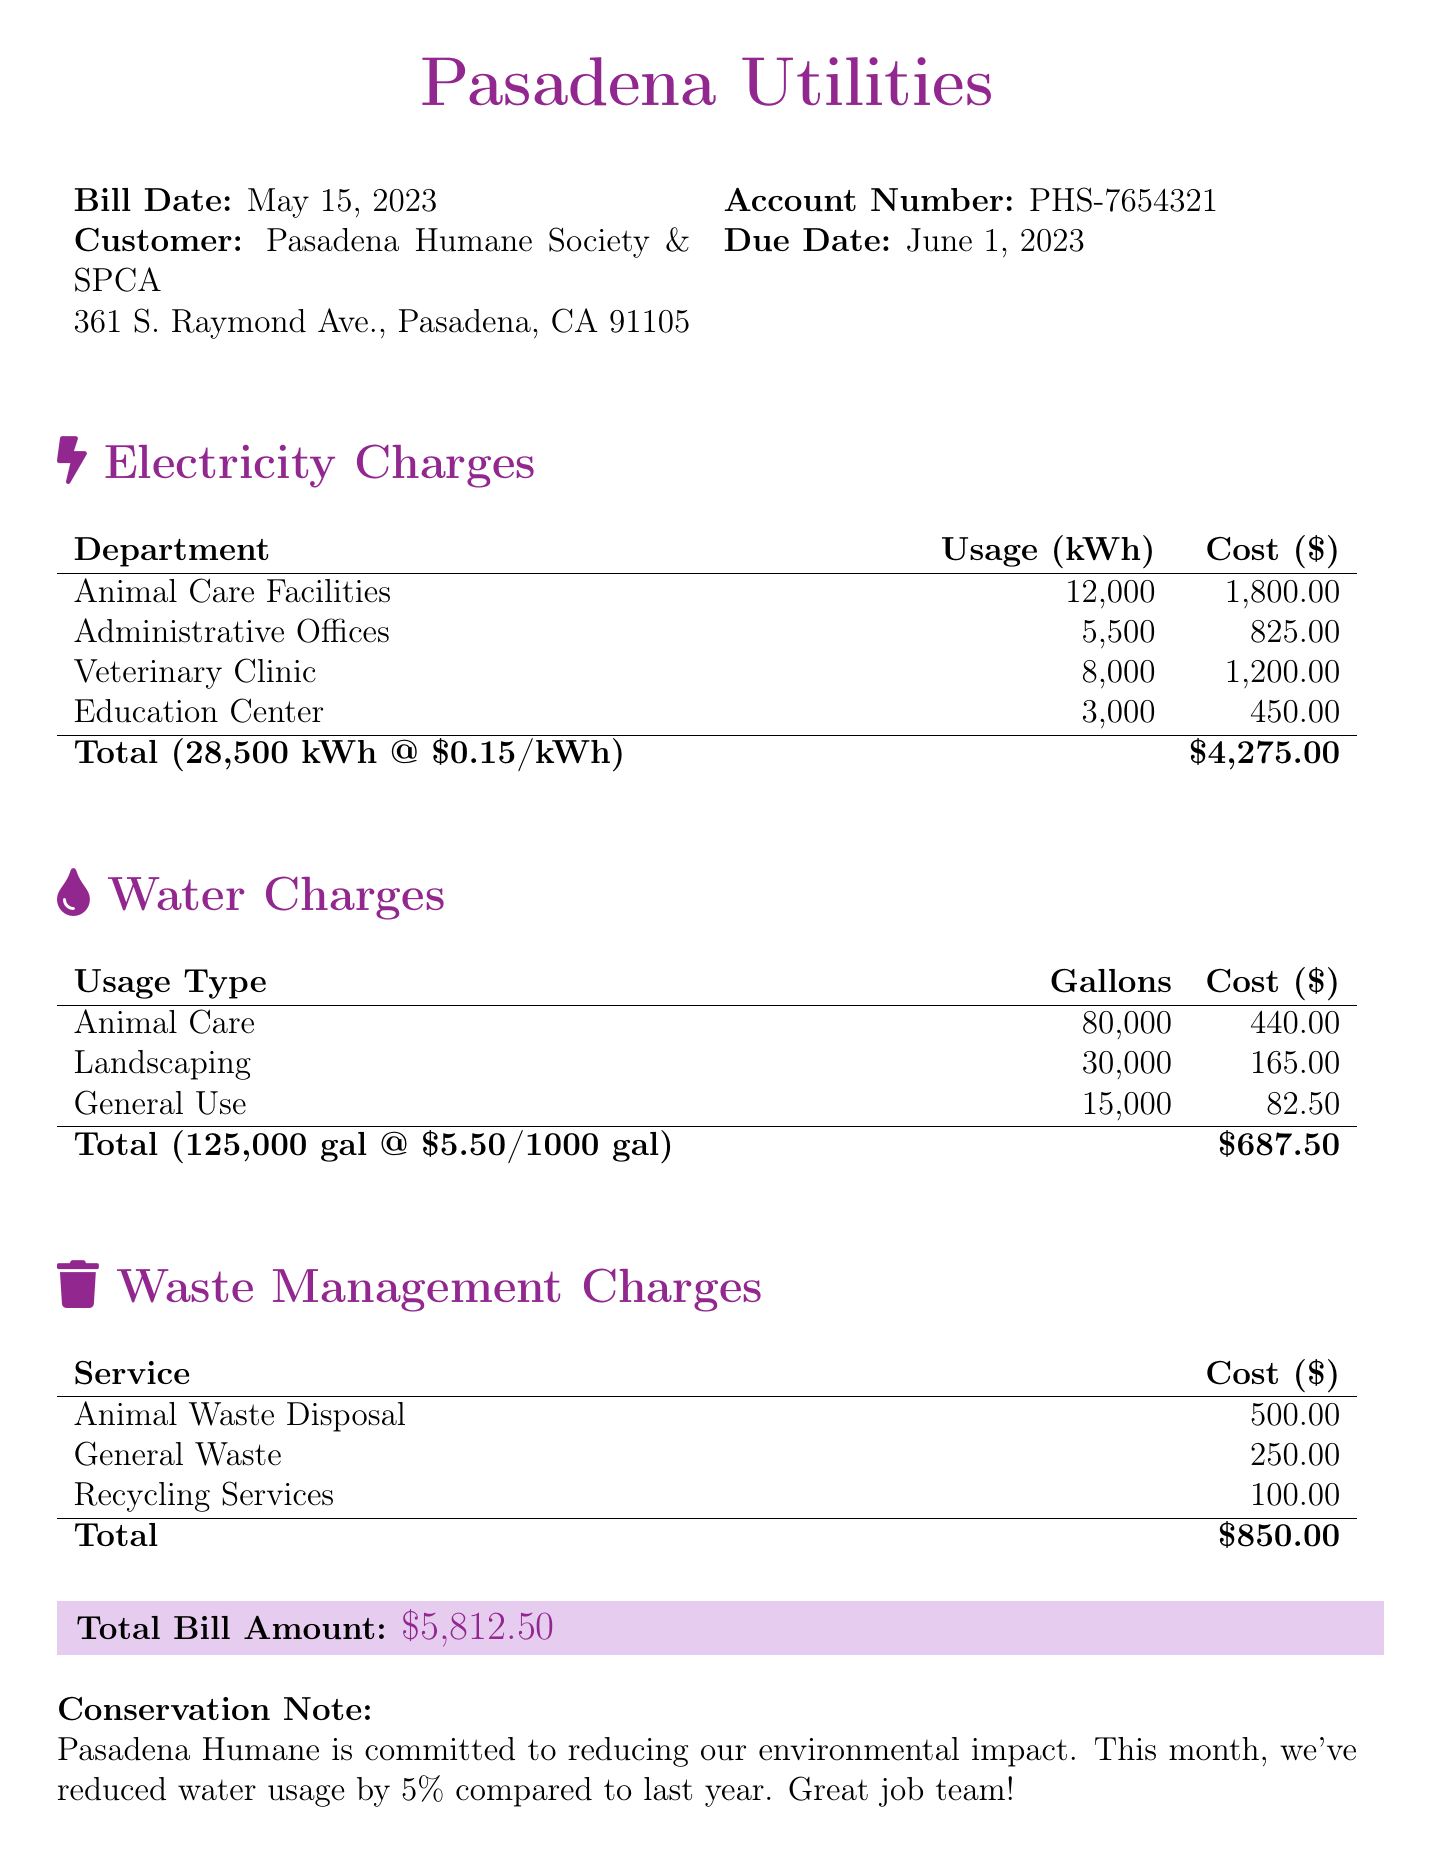What is the bill date? The bill date is specified at the top of the document, which is May 15, 2023.
Answer: May 15, 2023 What is the total cost of electricity charges? The total cost of electricity charges is found in the breakdown section for electricity, which sums up to four thousand two hundred seventy-five dollars.
Answer: $4,275.00 How much water was used for landscaping? The water usage for landscaping is detailed in the water charges section, indicating thirty thousand gallons.
Answer: 30,000 What is the total bill amount? The total bill amount is clearly stated at the bottom of the document, which combines all charges.
Answer: $5,812.50 What department used the most electricity? The department with the highest electricity usage is identified in the chart for electricity charges, which shows Animal Care Facilities used twelve thousand kWh.
Answer: Animal Care Facilities What was the total water usage? The total water usage is calculated from the table in the water charges section, which adds up to one hundred twenty-five thousand gallons.
Answer: 125,000 How much was spent on waste management services? The total waste management costs are presented in the waste management charges section, combining to eight hundred fifty dollars.
Answer: $850.00 What is the conservation note about? The conservation note provides information about Pasadena Humane's commitment to reducing environmental impact, mentioning a five percent reduction in water usage.
Answer: Water usage reduction by 5% What is the account number for the Pasadena Humane Society? The account number is located near the top of the document, which is indicated as PHS-7654321.
Answer: PHS-7654321 